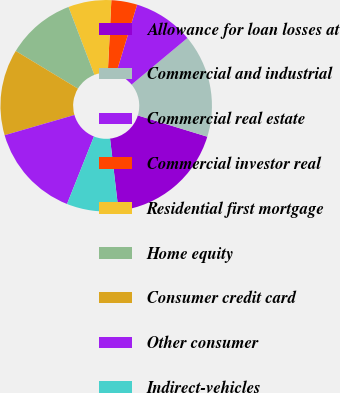<chart> <loc_0><loc_0><loc_500><loc_500><pie_chart><fcel>Allowance for loan losses at<fcel>Commercial and industrial<fcel>Commercial real estate<fcel>Commercial investor real<fcel>Residential first mortgage<fcel>Home equity<fcel>Consumer credit card<fcel>Other consumer<fcel>Indirect-vehicles<nl><fcel>18.42%<fcel>15.79%<fcel>9.21%<fcel>3.95%<fcel>6.58%<fcel>10.53%<fcel>13.16%<fcel>14.47%<fcel>7.9%<nl></chart> 